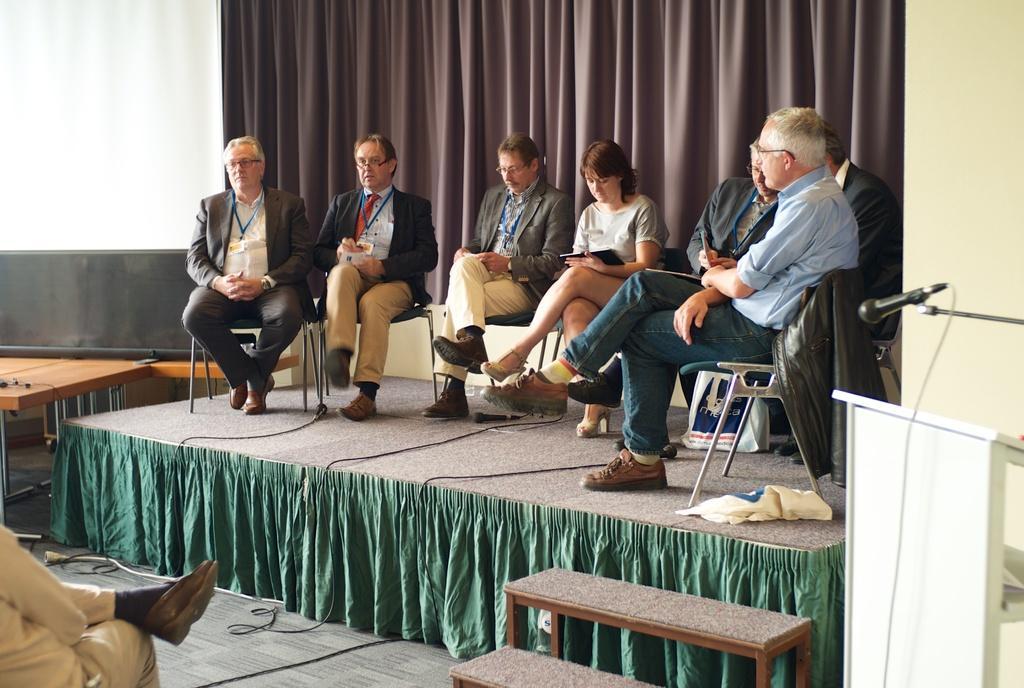Can you describe this image briefly? There are group of persons in different color dresses sitting on chairs, which are on the stage. In front of them, there is another person sitting on a char, which is on the floor. On the right side, there is a white color stand near a mic and stand. On the left side, there is a screen near a wooden table. In the background, there is a curtain. 